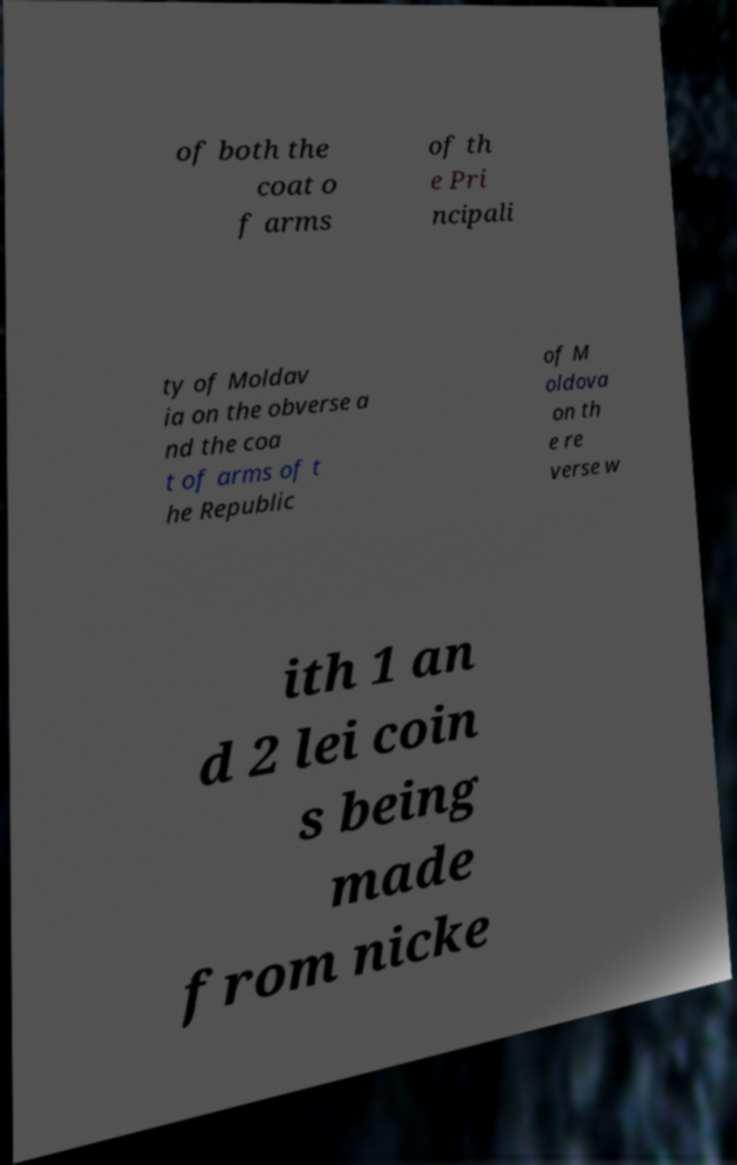Please read and relay the text visible in this image. What does it say? of both the coat o f arms of th e Pri ncipali ty of Moldav ia on the obverse a nd the coa t of arms of t he Republic of M oldova on th e re verse w ith 1 an d 2 lei coin s being made from nicke 